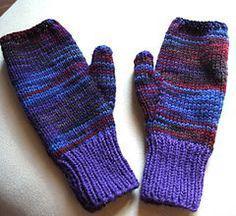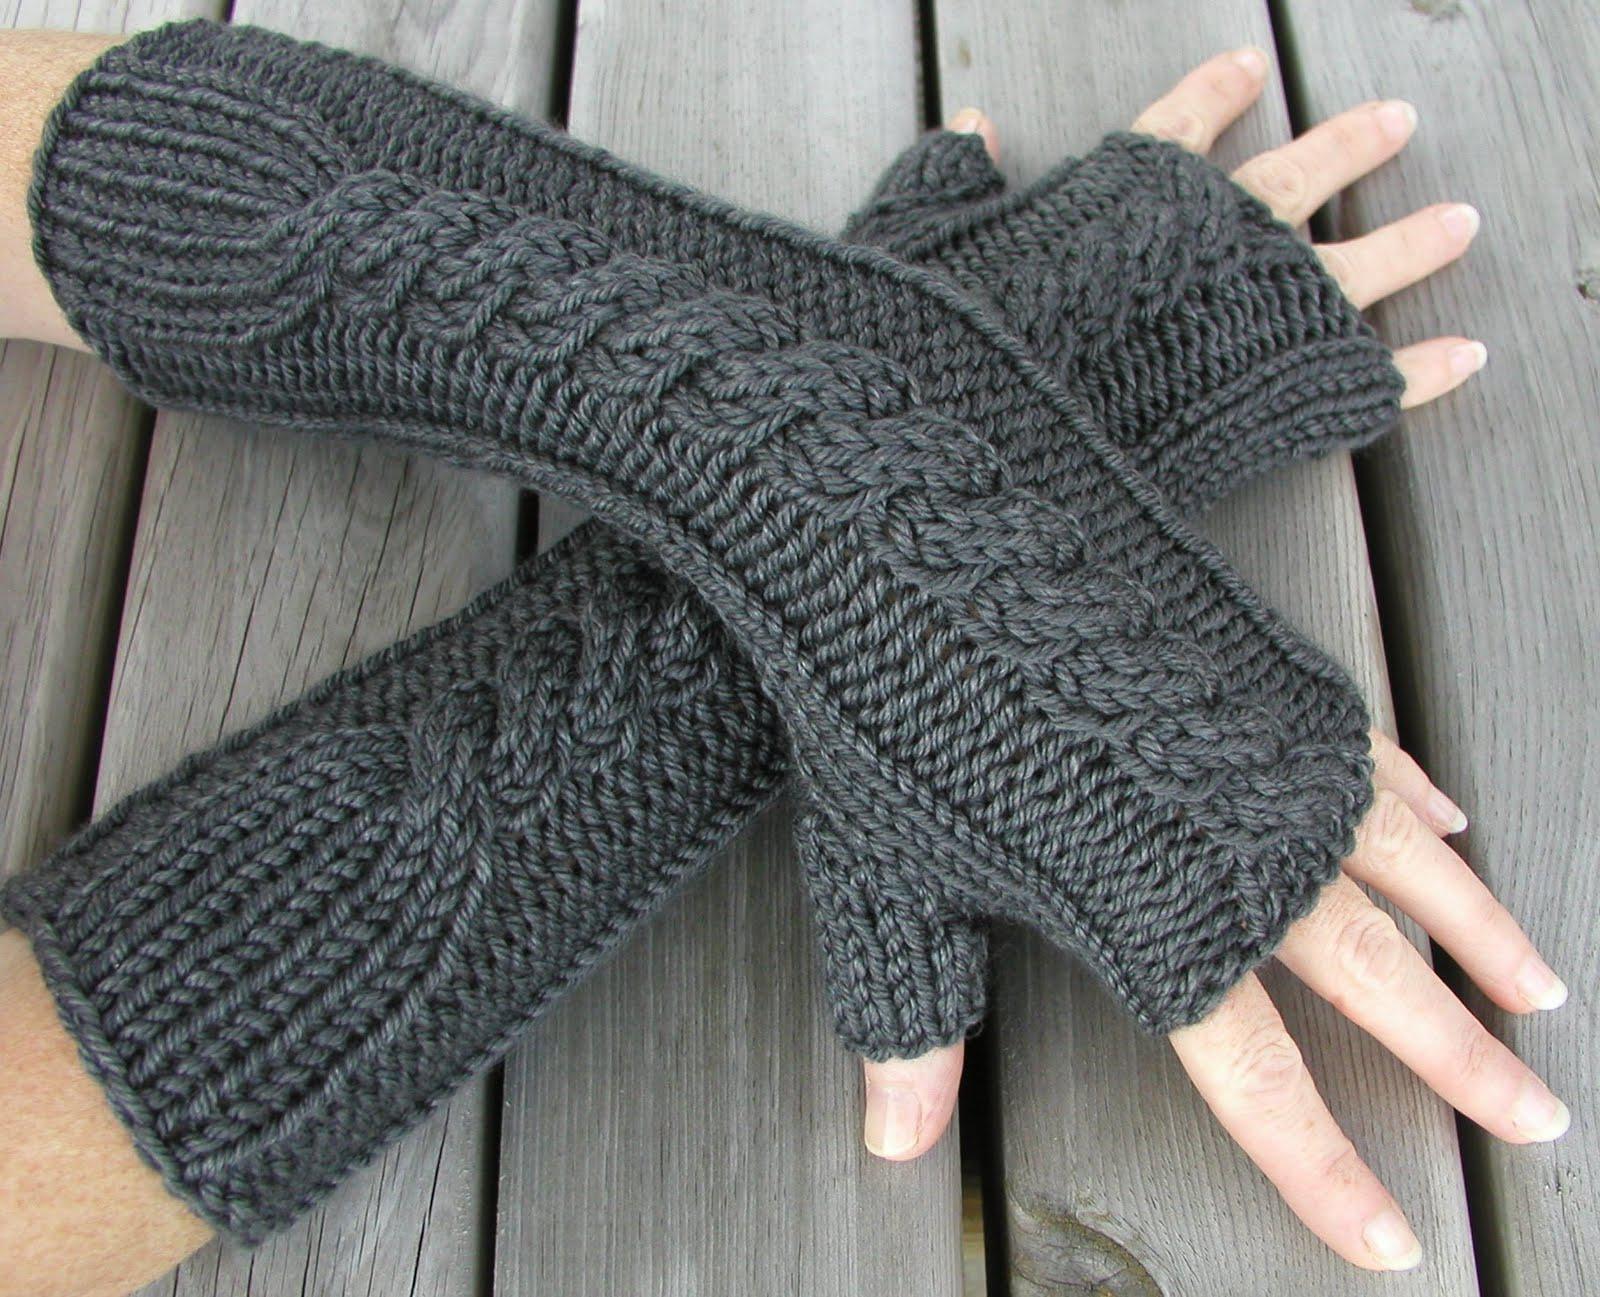The first image is the image on the left, the second image is the image on the right. Given the left and right images, does the statement "Both images feature a soild-colored fingerless yarn mitten modeled by a human hand." hold true? Answer yes or no. No. 